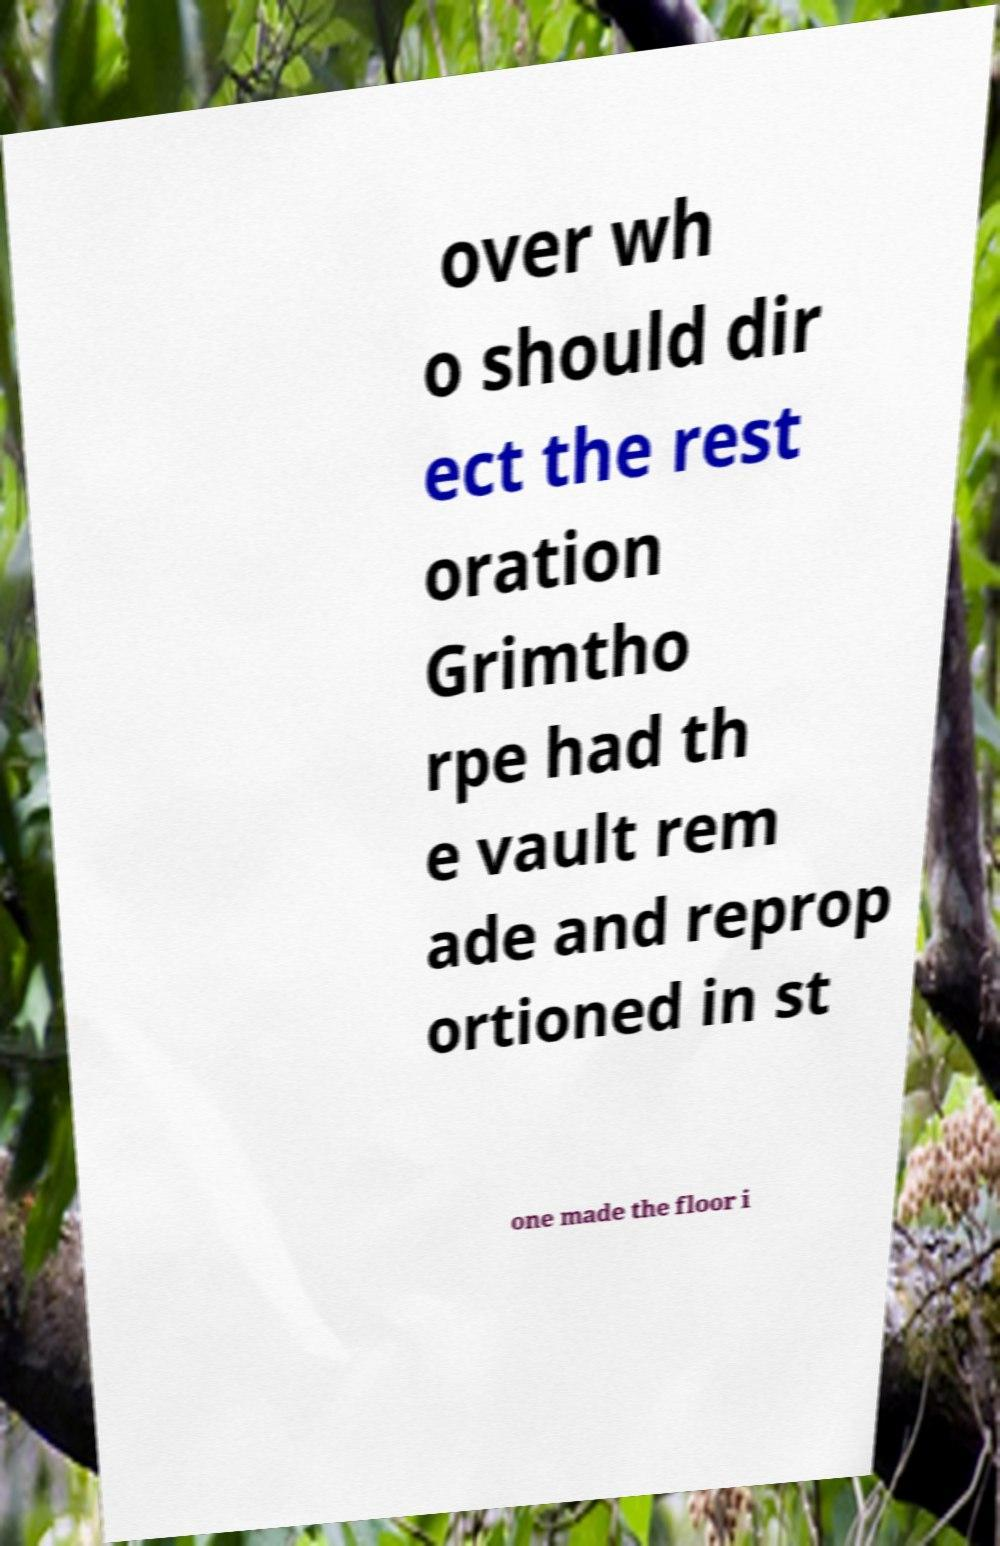For documentation purposes, I need the text within this image transcribed. Could you provide that? over wh o should dir ect the rest oration Grimtho rpe had th e vault rem ade and reprop ortioned in st one made the floor i 